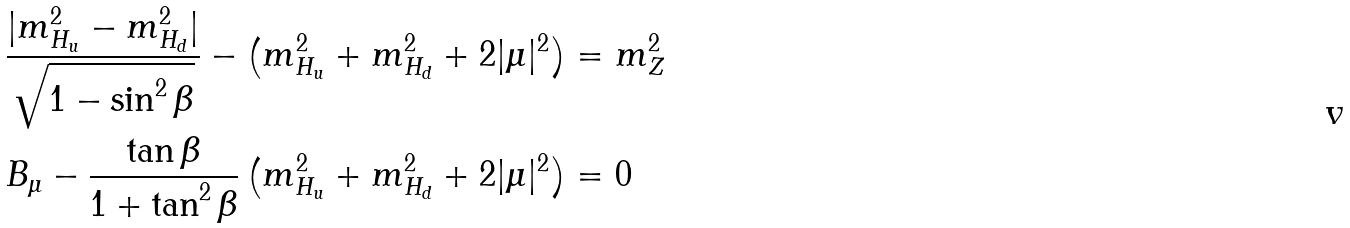Convert formula to latex. <formula><loc_0><loc_0><loc_500><loc_500>\frac { | m _ { H _ { u } } ^ { 2 } - m _ { H _ { d } } ^ { 2 } | } { \sqrt { 1 - \sin ^ { 2 } \beta } } - \left ( m _ { H _ { u } } ^ { 2 } + m _ { H _ { d } } ^ { 2 } + 2 | \mu | ^ { 2 } \right ) & = m _ { Z } ^ { 2 } \, \\ B _ { \mu } - \frac { \tan \beta } { 1 + \tan ^ { 2 } \beta } \left ( m _ { H _ { u } } ^ { 2 } + m _ { H _ { d } } ^ { 2 } + 2 | \mu | ^ { 2 } \right ) & = 0 \,</formula> 